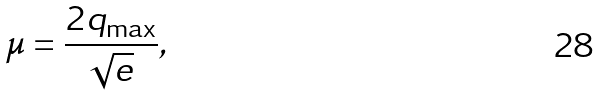<formula> <loc_0><loc_0><loc_500><loc_500>\mu = \frac { 2 q _ { \max } } { \sqrt { e } } ,</formula> 